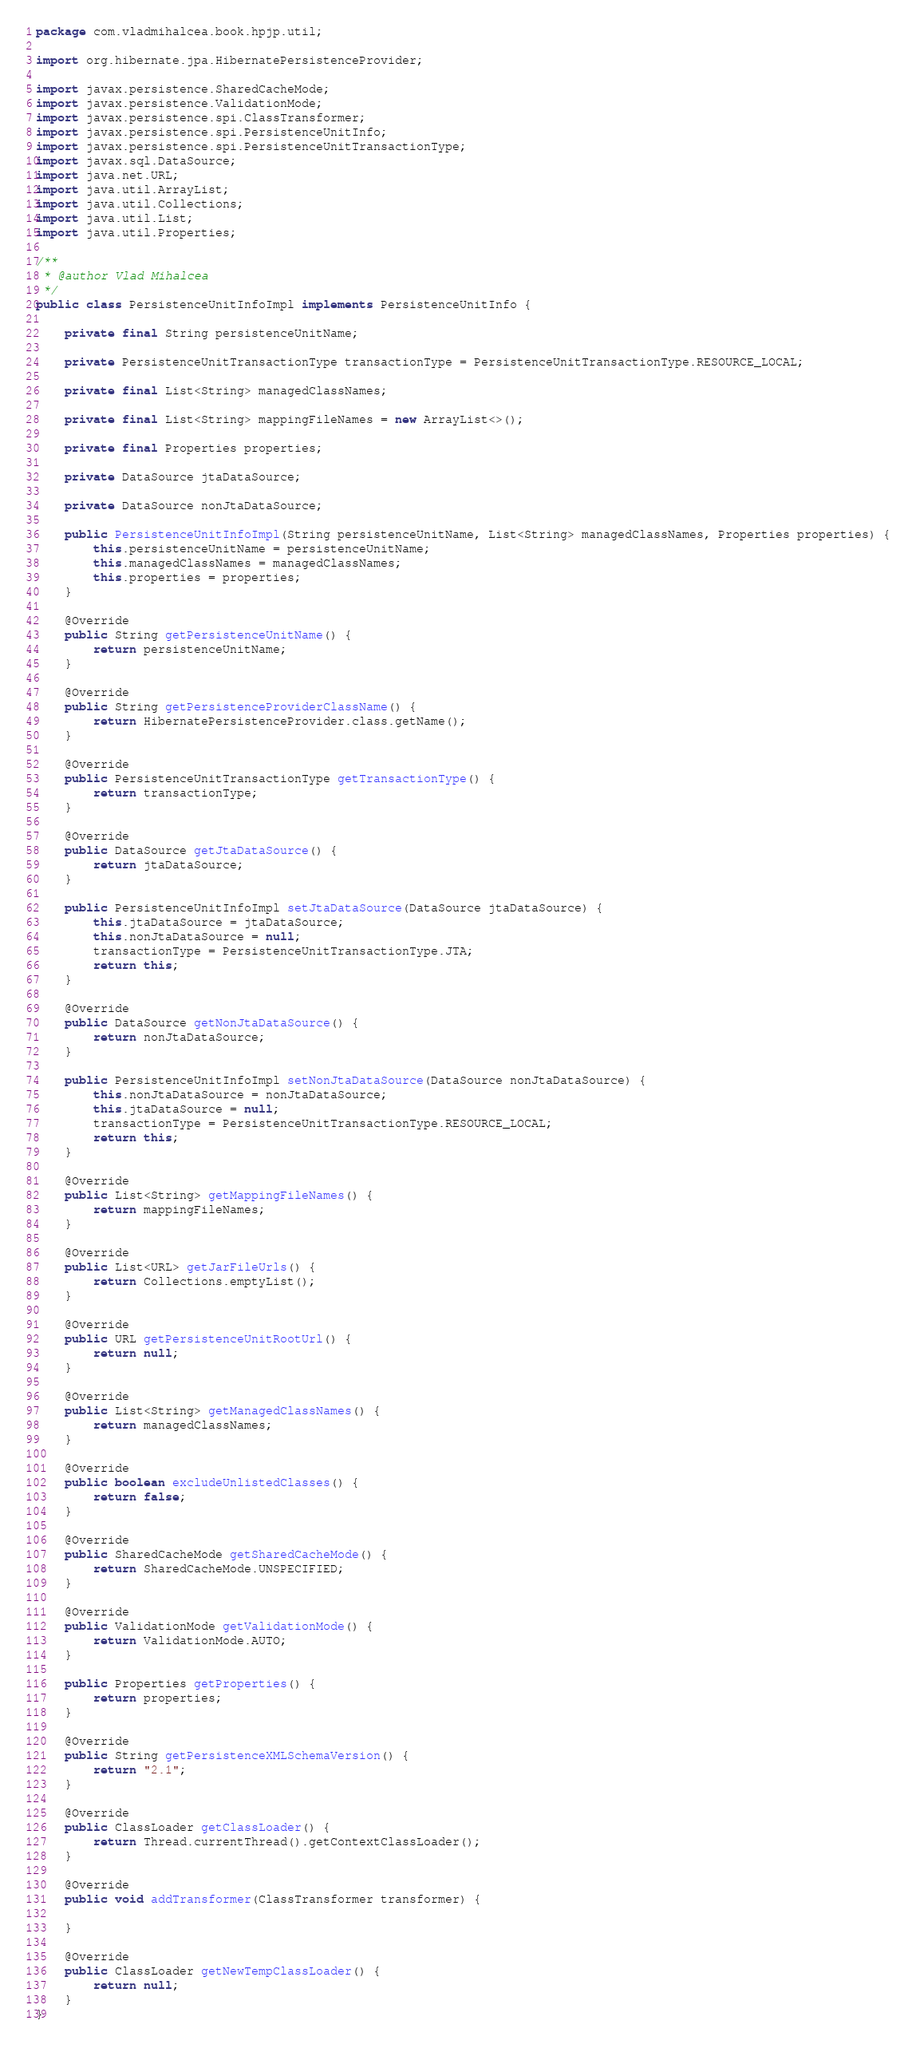<code> <loc_0><loc_0><loc_500><loc_500><_Java_>package com.vladmihalcea.book.hpjp.util;

import org.hibernate.jpa.HibernatePersistenceProvider;

import javax.persistence.SharedCacheMode;
import javax.persistence.ValidationMode;
import javax.persistence.spi.ClassTransformer;
import javax.persistence.spi.PersistenceUnitInfo;
import javax.persistence.spi.PersistenceUnitTransactionType;
import javax.sql.DataSource;
import java.net.URL;
import java.util.ArrayList;
import java.util.Collections;
import java.util.List;
import java.util.Properties;

/**
 * @author Vlad Mihalcea
 */
public class PersistenceUnitInfoImpl implements PersistenceUnitInfo {

    private final String persistenceUnitName;

    private PersistenceUnitTransactionType transactionType = PersistenceUnitTransactionType.RESOURCE_LOCAL;

    private final List<String> managedClassNames;

    private final List<String> mappingFileNames = new ArrayList<>();

    private final Properties properties;

    private DataSource jtaDataSource;

    private DataSource nonJtaDataSource;

    public PersistenceUnitInfoImpl(String persistenceUnitName, List<String> managedClassNames, Properties properties) {
        this.persistenceUnitName = persistenceUnitName;
        this.managedClassNames = managedClassNames;
        this.properties = properties;
    }

    @Override
    public String getPersistenceUnitName() {
        return persistenceUnitName;
    }

    @Override
    public String getPersistenceProviderClassName() {
        return HibernatePersistenceProvider.class.getName();
    }

    @Override
    public PersistenceUnitTransactionType getTransactionType() {
        return transactionType;
    }

    @Override
    public DataSource getJtaDataSource() {
        return jtaDataSource;
    }

    public PersistenceUnitInfoImpl setJtaDataSource(DataSource jtaDataSource) {
        this.jtaDataSource = jtaDataSource;
        this.nonJtaDataSource = null;
        transactionType = PersistenceUnitTransactionType.JTA;
        return this;
    }

    @Override
    public DataSource getNonJtaDataSource() {
        return nonJtaDataSource;
    }

    public PersistenceUnitInfoImpl setNonJtaDataSource(DataSource nonJtaDataSource) {
        this.nonJtaDataSource = nonJtaDataSource;
        this.jtaDataSource = null;
        transactionType = PersistenceUnitTransactionType.RESOURCE_LOCAL;
        return this;
    }

    @Override
    public List<String> getMappingFileNames() {
        return mappingFileNames;
    }

    @Override
    public List<URL> getJarFileUrls() {
        return Collections.emptyList();
    }

    @Override
    public URL getPersistenceUnitRootUrl() {
        return null;
    }

    @Override
    public List<String> getManagedClassNames() {
        return managedClassNames;
    }

    @Override
    public boolean excludeUnlistedClasses() {
        return false;
    }

    @Override
    public SharedCacheMode getSharedCacheMode() {
        return SharedCacheMode.UNSPECIFIED;
    }

    @Override
    public ValidationMode getValidationMode() {
        return ValidationMode.AUTO;
    }

    public Properties getProperties() {
        return properties;
    }

    @Override
    public String getPersistenceXMLSchemaVersion() {
        return "2.1";
    }

    @Override
    public ClassLoader getClassLoader() {
        return Thread.currentThread().getContextClassLoader();
    }

    @Override
    public void addTransformer(ClassTransformer transformer) {

    }

    @Override
    public ClassLoader getNewTempClassLoader() {
        return null;
    }
}
</code> 